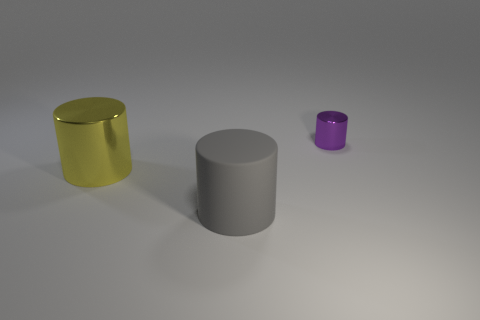Add 3 gray rubber things. How many objects exist? 6 Subtract all large matte cylinders. Subtract all large yellow shiny cylinders. How many objects are left? 1 Add 2 large metallic objects. How many large metallic objects are left? 3 Add 3 brown matte cubes. How many brown matte cubes exist? 3 Subtract 0 brown blocks. How many objects are left? 3 